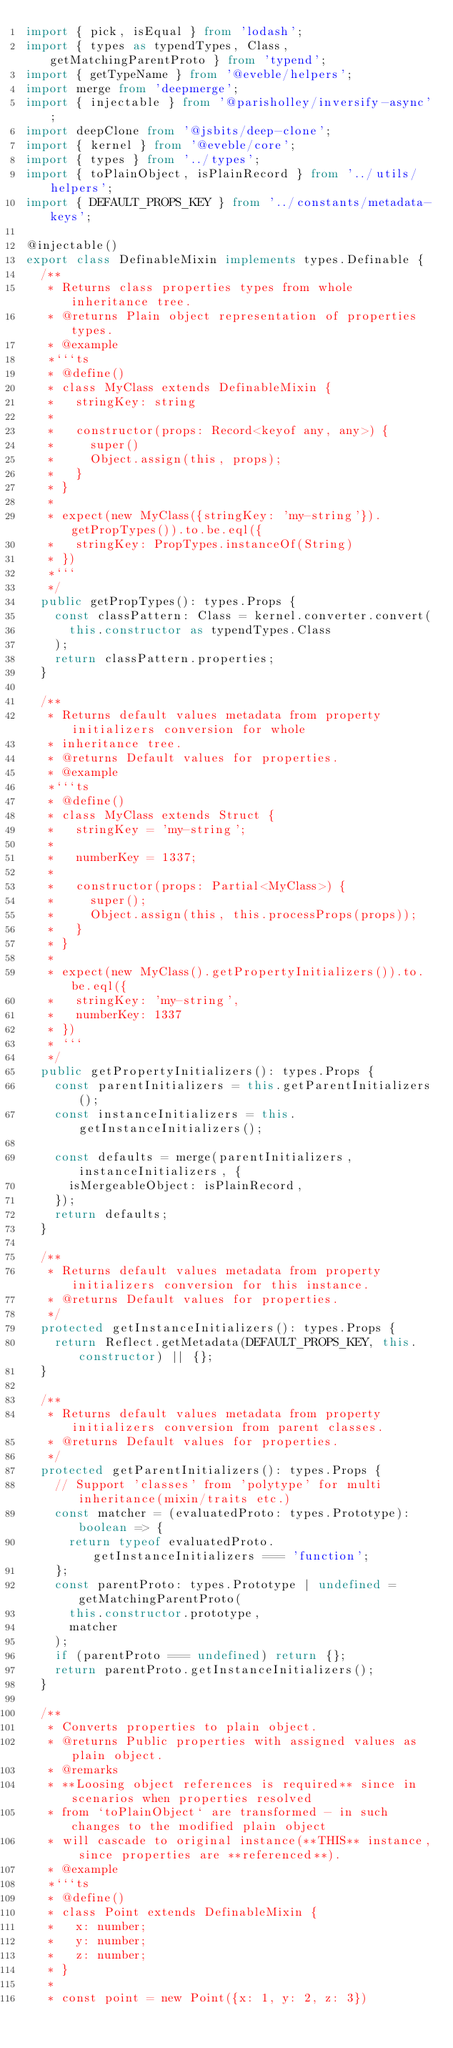<code> <loc_0><loc_0><loc_500><loc_500><_TypeScript_>import { pick, isEqual } from 'lodash';
import { types as typendTypes, Class, getMatchingParentProto } from 'typend';
import { getTypeName } from '@eveble/helpers';
import merge from 'deepmerge';
import { injectable } from '@parisholley/inversify-async';
import deepClone from '@jsbits/deep-clone';
import { kernel } from '@eveble/core';
import { types } from '../types';
import { toPlainObject, isPlainRecord } from '../utils/helpers';
import { DEFAULT_PROPS_KEY } from '../constants/metadata-keys';

@injectable()
export class DefinableMixin implements types.Definable {
  /**
   * Returns class properties types from whole inheritance tree.
   * @returns Plain object representation of properties types.
   * @example
   *```ts
   * @define()
   * class MyClass extends DefinableMixin {
   *   stringKey: string
   *
   *   constructor(props: Record<keyof any, any>) {
   *     super()
   *     Object.assign(this, props);
   *   }
   * }
   *
   * expect(new MyClass({stringKey: 'my-string'}).getPropTypes()).to.be.eql({
   *   stringKey: PropTypes.instanceOf(String)
   * })
   *```
   */
  public getPropTypes(): types.Props {
    const classPattern: Class = kernel.converter.convert(
      this.constructor as typendTypes.Class
    );
    return classPattern.properties;
  }

  /**
   * Returns default values metadata from property initializers conversion for whole
   * inheritance tree.
   * @returns Default values for properties.
   * @example
   *```ts
   * @define()
   * class MyClass extends Struct {
   *   stringKey = 'my-string';
   *
   *   numberKey = 1337;
   *
   *   constructor(props: Partial<MyClass>) {
   *     super();
   *     Object.assign(this, this.processProps(props));
   *   }
   * }
   *
   * expect(new MyClass().getPropertyInitializers()).to.be.eql({
   *   stringKey: 'my-string',
   *   numberKey: 1337
   * })
   * ```
   */
  public getPropertyInitializers(): types.Props {
    const parentInitializers = this.getParentInitializers();
    const instanceInitializers = this.getInstanceInitializers();

    const defaults = merge(parentInitializers, instanceInitializers, {
      isMergeableObject: isPlainRecord,
    });
    return defaults;
  }

  /**
   * Returns default values metadata from property initializers conversion for this instance.
   * @returns Default values for properties.
   */
  protected getInstanceInitializers(): types.Props {
    return Reflect.getMetadata(DEFAULT_PROPS_KEY, this.constructor) || {};
  }

  /**
   * Returns default values metadata from property initializers conversion from parent classes.
   * @returns Default values for properties.
   */
  protected getParentInitializers(): types.Props {
    // Support 'classes' from 'polytype' for multi inheritance(mixin/traits etc.)
    const matcher = (evaluatedProto: types.Prototype): boolean => {
      return typeof evaluatedProto.getInstanceInitializers === 'function';
    };
    const parentProto: types.Prototype | undefined = getMatchingParentProto(
      this.constructor.prototype,
      matcher
    );
    if (parentProto === undefined) return {};
    return parentProto.getInstanceInitializers();
  }

  /**
   * Converts properties to plain object.
   * @returns Public properties with assigned values as plain object.
   * @remarks
   * **Loosing object references is required** since in scenarios when properties resolved
   * from `toPlainObject` are transformed - in such changes to the modified plain object
   * will cascade to original instance(**THIS** instance, since properties are **referenced**).
   * @example
   *```ts
   * @define()
   * class Point extends DefinableMixin {
   *   x: number;
   *   y: number;
   *   z: number;
   * }
   *
   * const point = new Point({x: 1, y: 2, z: 3})</code> 